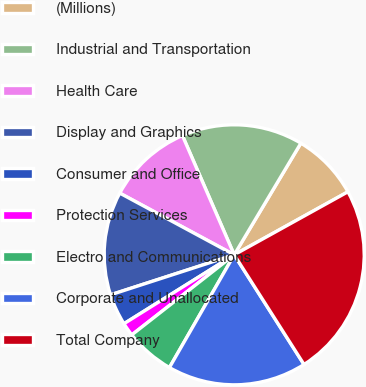<chart> <loc_0><loc_0><loc_500><loc_500><pie_chart><fcel>(Millions)<fcel>Industrial and Transportation<fcel>Health Care<fcel>Display and Graphics<fcel>Consumer and Office<fcel>Protection Services<fcel>Electro and Communications<fcel>Corporate and Unallocated<fcel>Total Company<nl><fcel>8.38%<fcel>15.09%<fcel>10.61%<fcel>12.85%<fcel>3.91%<fcel>1.67%<fcel>6.14%<fcel>17.32%<fcel>24.03%<nl></chart> 